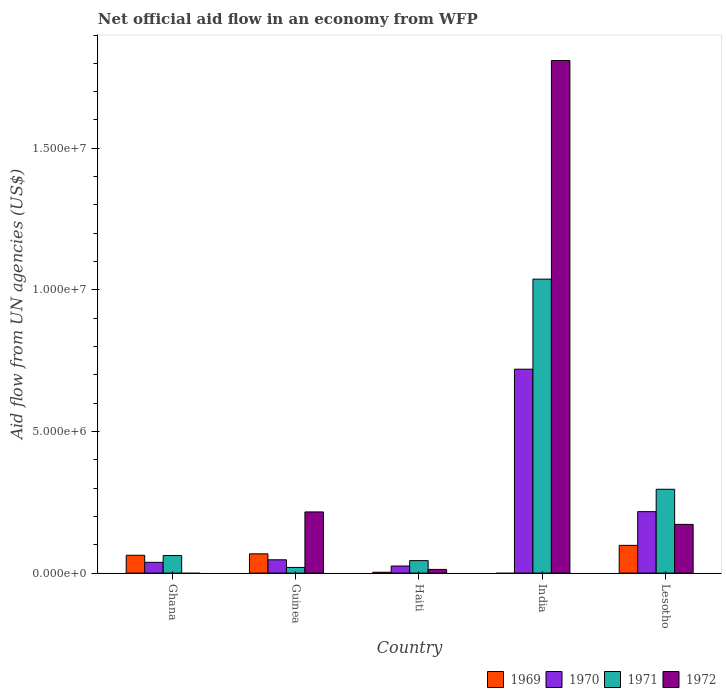How many different coloured bars are there?
Provide a succinct answer. 4. Are the number of bars on each tick of the X-axis equal?
Offer a terse response. No. How many bars are there on the 3rd tick from the left?
Ensure brevity in your answer.  4. How many bars are there on the 1st tick from the right?
Ensure brevity in your answer.  4. What is the label of the 3rd group of bars from the left?
Give a very brief answer. Haiti. In how many cases, is the number of bars for a given country not equal to the number of legend labels?
Offer a terse response. 2. Across all countries, what is the maximum net official aid flow in 1971?
Keep it short and to the point. 1.04e+07. In which country was the net official aid flow in 1972 maximum?
Provide a short and direct response. India. What is the total net official aid flow in 1970 in the graph?
Provide a succinct answer. 1.05e+07. What is the difference between the net official aid flow in 1970 in Ghana and that in India?
Keep it short and to the point. -6.82e+06. What is the average net official aid flow in 1971 per country?
Offer a terse response. 2.92e+06. What is the difference between the net official aid flow of/in 1971 and net official aid flow of/in 1969 in Guinea?
Keep it short and to the point. -4.80e+05. In how many countries, is the net official aid flow in 1969 greater than 12000000 US$?
Keep it short and to the point. 0. What is the ratio of the net official aid flow in 1971 in Haiti to that in Lesotho?
Your answer should be compact. 0.15. Is the net official aid flow in 1971 in Haiti less than that in India?
Give a very brief answer. Yes. What is the difference between the highest and the lowest net official aid flow in 1969?
Make the answer very short. 9.80e+05. In how many countries, is the net official aid flow in 1972 greater than the average net official aid flow in 1972 taken over all countries?
Offer a very short reply. 1. Is the sum of the net official aid flow in 1971 in Haiti and Lesotho greater than the maximum net official aid flow in 1972 across all countries?
Ensure brevity in your answer.  No. Is it the case that in every country, the sum of the net official aid flow in 1970 and net official aid flow in 1969 is greater than the sum of net official aid flow in 1971 and net official aid flow in 1972?
Provide a short and direct response. No. How many bars are there?
Offer a terse response. 18. Where does the legend appear in the graph?
Provide a succinct answer. Bottom right. How many legend labels are there?
Make the answer very short. 4. What is the title of the graph?
Ensure brevity in your answer.  Net official aid flow in an economy from WFP. Does "1973" appear as one of the legend labels in the graph?
Make the answer very short. No. What is the label or title of the X-axis?
Your answer should be compact. Country. What is the label or title of the Y-axis?
Provide a succinct answer. Aid flow from UN agencies (US$). What is the Aid flow from UN agencies (US$) in 1969 in Ghana?
Give a very brief answer. 6.30e+05. What is the Aid flow from UN agencies (US$) of 1970 in Ghana?
Keep it short and to the point. 3.80e+05. What is the Aid flow from UN agencies (US$) of 1971 in Ghana?
Keep it short and to the point. 6.20e+05. What is the Aid flow from UN agencies (US$) in 1972 in Ghana?
Offer a very short reply. 0. What is the Aid flow from UN agencies (US$) of 1969 in Guinea?
Offer a very short reply. 6.80e+05. What is the Aid flow from UN agencies (US$) in 1971 in Guinea?
Make the answer very short. 2.00e+05. What is the Aid flow from UN agencies (US$) in 1972 in Guinea?
Offer a very short reply. 2.16e+06. What is the Aid flow from UN agencies (US$) of 1969 in Haiti?
Your response must be concise. 3.00e+04. What is the Aid flow from UN agencies (US$) in 1971 in Haiti?
Your answer should be compact. 4.40e+05. What is the Aid flow from UN agencies (US$) in 1972 in Haiti?
Ensure brevity in your answer.  1.30e+05. What is the Aid flow from UN agencies (US$) of 1970 in India?
Ensure brevity in your answer.  7.20e+06. What is the Aid flow from UN agencies (US$) in 1971 in India?
Keep it short and to the point. 1.04e+07. What is the Aid flow from UN agencies (US$) in 1972 in India?
Keep it short and to the point. 1.81e+07. What is the Aid flow from UN agencies (US$) in 1969 in Lesotho?
Your response must be concise. 9.80e+05. What is the Aid flow from UN agencies (US$) of 1970 in Lesotho?
Provide a succinct answer. 2.17e+06. What is the Aid flow from UN agencies (US$) in 1971 in Lesotho?
Provide a short and direct response. 2.96e+06. What is the Aid flow from UN agencies (US$) of 1972 in Lesotho?
Your answer should be very brief. 1.72e+06. Across all countries, what is the maximum Aid flow from UN agencies (US$) in 1969?
Provide a short and direct response. 9.80e+05. Across all countries, what is the maximum Aid flow from UN agencies (US$) of 1970?
Your response must be concise. 7.20e+06. Across all countries, what is the maximum Aid flow from UN agencies (US$) of 1971?
Your answer should be compact. 1.04e+07. Across all countries, what is the maximum Aid flow from UN agencies (US$) of 1972?
Provide a short and direct response. 1.81e+07. Across all countries, what is the minimum Aid flow from UN agencies (US$) in 1969?
Your answer should be compact. 0. Across all countries, what is the minimum Aid flow from UN agencies (US$) in 1971?
Your response must be concise. 2.00e+05. Across all countries, what is the minimum Aid flow from UN agencies (US$) in 1972?
Keep it short and to the point. 0. What is the total Aid flow from UN agencies (US$) of 1969 in the graph?
Your answer should be compact. 2.32e+06. What is the total Aid flow from UN agencies (US$) of 1970 in the graph?
Your answer should be very brief. 1.05e+07. What is the total Aid flow from UN agencies (US$) in 1971 in the graph?
Give a very brief answer. 1.46e+07. What is the total Aid flow from UN agencies (US$) in 1972 in the graph?
Your response must be concise. 2.21e+07. What is the difference between the Aid flow from UN agencies (US$) of 1969 in Ghana and that in Guinea?
Keep it short and to the point. -5.00e+04. What is the difference between the Aid flow from UN agencies (US$) in 1970 in Ghana and that in Guinea?
Give a very brief answer. -9.00e+04. What is the difference between the Aid flow from UN agencies (US$) of 1971 in Ghana and that in Haiti?
Ensure brevity in your answer.  1.80e+05. What is the difference between the Aid flow from UN agencies (US$) in 1970 in Ghana and that in India?
Provide a short and direct response. -6.82e+06. What is the difference between the Aid flow from UN agencies (US$) of 1971 in Ghana and that in India?
Your answer should be compact. -9.76e+06. What is the difference between the Aid flow from UN agencies (US$) of 1969 in Ghana and that in Lesotho?
Offer a very short reply. -3.50e+05. What is the difference between the Aid flow from UN agencies (US$) in 1970 in Ghana and that in Lesotho?
Give a very brief answer. -1.79e+06. What is the difference between the Aid flow from UN agencies (US$) of 1971 in Ghana and that in Lesotho?
Keep it short and to the point. -2.34e+06. What is the difference between the Aid flow from UN agencies (US$) in 1969 in Guinea and that in Haiti?
Your response must be concise. 6.50e+05. What is the difference between the Aid flow from UN agencies (US$) of 1971 in Guinea and that in Haiti?
Your response must be concise. -2.40e+05. What is the difference between the Aid flow from UN agencies (US$) of 1972 in Guinea and that in Haiti?
Keep it short and to the point. 2.03e+06. What is the difference between the Aid flow from UN agencies (US$) in 1970 in Guinea and that in India?
Ensure brevity in your answer.  -6.73e+06. What is the difference between the Aid flow from UN agencies (US$) in 1971 in Guinea and that in India?
Offer a terse response. -1.02e+07. What is the difference between the Aid flow from UN agencies (US$) in 1972 in Guinea and that in India?
Keep it short and to the point. -1.59e+07. What is the difference between the Aid flow from UN agencies (US$) in 1969 in Guinea and that in Lesotho?
Your answer should be very brief. -3.00e+05. What is the difference between the Aid flow from UN agencies (US$) in 1970 in Guinea and that in Lesotho?
Make the answer very short. -1.70e+06. What is the difference between the Aid flow from UN agencies (US$) of 1971 in Guinea and that in Lesotho?
Keep it short and to the point. -2.76e+06. What is the difference between the Aid flow from UN agencies (US$) in 1972 in Guinea and that in Lesotho?
Your answer should be compact. 4.40e+05. What is the difference between the Aid flow from UN agencies (US$) in 1970 in Haiti and that in India?
Offer a terse response. -6.95e+06. What is the difference between the Aid flow from UN agencies (US$) in 1971 in Haiti and that in India?
Offer a very short reply. -9.94e+06. What is the difference between the Aid flow from UN agencies (US$) of 1972 in Haiti and that in India?
Give a very brief answer. -1.80e+07. What is the difference between the Aid flow from UN agencies (US$) in 1969 in Haiti and that in Lesotho?
Ensure brevity in your answer.  -9.50e+05. What is the difference between the Aid flow from UN agencies (US$) of 1970 in Haiti and that in Lesotho?
Give a very brief answer. -1.92e+06. What is the difference between the Aid flow from UN agencies (US$) of 1971 in Haiti and that in Lesotho?
Your response must be concise. -2.52e+06. What is the difference between the Aid flow from UN agencies (US$) of 1972 in Haiti and that in Lesotho?
Your response must be concise. -1.59e+06. What is the difference between the Aid flow from UN agencies (US$) in 1970 in India and that in Lesotho?
Give a very brief answer. 5.03e+06. What is the difference between the Aid flow from UN agencies (US$) in 1971 in India and that in Lesotho?
Keep it short and to the point. 7.42e+06. What is the difference between the Aid flow from UN agencies (US$) of 1972 in India and that in Lesotho?
Offer a very short reply. 1.64e+07. What is the difference between the Aid flow from UN agencies (US$) in 1969 in Ghana and the Aid flow from UN agencies (US$) in 1970 in Guinea?
Make the answer very short. 1.60e+05. What is the difference between the Aid flow from UN agencies (US$) of 1969 in Ghana and the Aid flow from UN agencies (US$) of 1971 in Guinea?
Offer a very short reply. 4.30e+05. What is the difference between the Aid flow from UN agencies (US$) in 1969 in Ghana and the Aid flow from UN agencies (US$) in 1972 in Guinea?
Make the answer very short. -1.53e+06. What is the difference between the Aid flow from UN agencies (US$) in 1970 in Ghana and the Aid flow from UN agencies (US$) in 1971 in Guinea?
Your answer should be compact. 1.80e+05. What is the difference between the Aid flow from UN agencies (US$) in 1970 in Ghana and the Aid flow from UN agencies (US$) in 1972 in Guinea?
Ensure brevity in your answer.  -1.78e+06. What is the difference between the Aid flow from UN agencies (US$) of 1971 in Ghana and the Aid flow from UN agencies (US$) of 1972 in Guinea?
Provide a short and direct response. -1.54e+06. What is the difference between the Aid flow from UN agencies (US$) of 1969 in Ghana and the Aid flow from UN agencies (US$) of 1970 in Haiti?
Make the answer very short. 3.80e+05. What is the difference between the Aid flow from UN agencies (US$) in 1970 in Ghana and the Aid flow from UN agencies (US$) in 1971 in Haiti?
Make the answer very short. -6.00e+04. What is the difference between the Aid flow from UN agencies (US$) of 1970 in Ghana and the Aid flow from UN agencies (US$) of 1972 in Haiti?
Make the answer very short. 2.50e+05. What is the difference between the Aid flow from UN agencies (US$) in 1971 in Ghana and the Aid flow from UN agencies (US$) in 1972 in Haiti?
Give a very brief answer. 4.90e+05. What is the difference between the Aid flow from UN agencies (US$) of 1969 in Ghana and the Aid flow from UN agencies (US$) of 1970 in India?
Provide a succinct answer. -6.57e+06. What is the difference between the Aid flow from UN agencies (US$) of 1969 in Ghana and the Aid flow from UN agencies (US$) of 1971 in India?
Your response must be concise. -9.75e+06. What is the difference between the Aid flow from UN agencies (US$) in 1969 in Ghana and the Aid flow from UN agencies (US$) in 1972 in India?
Your response must be concise. -1.75e+07. What is the difference between the Aid flow from UN agencies (US$) of 1970 in Ghana and the Aid flow from UN agencies (US$) of 1971 in India?
Your answer should be compact. -1.00e+07. What is the difference between the Aid flow from UN agencies (US$) of 1970 in Ghana and the Aid flow from UN agencies (US$) of 1972 in India?
Offer a terse response. -1.77e+07. What is the difference between the Aid flow from UN agencies (US$) in 1971 in Ghana and the Aid flow from UN agencies (US$) in 1972 in India?
Your response must be concise. -1.75e+07. What is the difference between the Aid flow from UN agencies (US$) of 1969 in Ghana and the Aid flow from UN agencies (US$) of 1970 in Lesotho?
Keep it short and to the point. -1.54e+06. What is the difference between the Aid flow from UN agencies (US$) of 1969 in Ghana and the Aid flow from UN agencies (US$) of 1971 in Lesotho?
Your response must be concise. -2.33e+06. What is the difference between the Aid flow from UN agencies (US$) in 1969 in Ghana and the Aid flow from UN agencies (US$) in 1972 in Lesotho?
Your response must be concise. -1.09e+06. What is the difference between the Aid flow from UN agencies (US$) of 1970 in Ghana and the Aid flow from UN agencies (US$) of 1971 in Lesotho?
Your answer should be compact. -2.58e+06. What is the difference between the Aid flow from UN agencies (US$) in 1970 in Ghana and the Aid flow from UN agencies (US$) in 1972 in Lesotho?
Offer a very short reply. -1.34e+06. What is the difference between the Aid flow from UN agencies (US$) of 1971 in Ghana and the Aid flow from UN agencies (US$) of 1972 in Lesotho?
Offer a very short reply. -1.10e+06. What is the difference between the Aid flow from UN agencies (US$) of 1970 in Guinea and the Aid flow from UN agencies (US$) of 1971 in Haiti?
Your answer should be compact. 3.00e+04. What is the difference between the Aid flow from UN agencies (US$) in 1970 in Guinea and the Aid flow from UN agencies (US$) in 1972 in Haiti?
Your response must be concise. 3.40e+05. What is the difference between the Aid flow from UN agencies (US$) in 1969 in Guinea and the Aid flow from UN agencies (US$) in 1970 in India?
Your answer should be very brief. -6.52e+06. What is the difference between the Aid flow from UN agencies (US$) in 1969 in Guinea and the Aid flow from UN agencies (US$) in 1971 in India?
Ensure brevity in your answer.  -9.70e+06. What is the difference between the Aid flow from UN agencies (US$) in 1969 in Guinea and the Aid flow from UN agencies (US$) in 1972 in India?
Your answer should be compact. -1.74e+07. What is the difference between the Aid flow from UN agencies (US$) of 1970 in Guinea and the Aid flow from UN agencies (US$) of 1971 in India?
Your answer should be very brief. -9.91e+06. What is the difference between the Aid flow from UN agencies (US$) of 1970 in Guinea and the Aid flow from UN agencies (US$) of 1972 in India?
Offer a very short reply. -1.76e+07. What is the difference between the Aid flow from UN agencies (US$) of 1971 in Guinea and the Aid flow from UN agencies (US$) of 1972 in India?
Offer a very short reply. -1.79e+07. What is the difference between the Aid flow from UN agencies (US$) in 1969 in Guinea and the Aid flow from UN agencies (US$) in 1970 in Lesotho?
Offer a terse response. -1.49e+06. What is the difference between the Aid flow from UN agencies (US$) of 1969 in Guinea and the Aid flow from UN agencies (US$) of 1971 in Lesotho?
Provide a short and direct response. -2.28e+06. What is the difference between the Aid flow from UN agencies (US$) of 1969 in Guinea and the Aid flow from UN agencies (US$) of 1972 in Lesotho?
Your answer should be very brief. -1.04e+06. What is the difference between the Aid flow from UN agencies (US$) of 1970 in Guinea and the Aid flow from UN agencies (US$) of 1971 in Lesotho?
Offer a very short reply. -2.49e+06. What is the difference between the Aid flow from UN agencies (US$) in 1970 in Guinea and the Aid flow from UN agencies (US$) in 1972 in Lesotho?
Make the answer very short. -1.25e+06. What is the difference between the Aid flow from UN agencies (US$) in 1971 in Guinea and the Aid flow from UN agencies (US$) in 1972 in Lesotho?
Offer a very short reply. -1.52e+06. What is the difference between the Aid flow from UN agencies (US$) of 1969 in Haiti and the Aid flow from UN agencies (US$) of 1970 in India?
Ensure brevity in your answer.  -7.17e+06. What is the difference between the Aid flow from UN agencies (US$) of 1969 in Haiti and the Aid flow from UN agencies (US$) of 1971 in India?
Provide a short and direct response. -1.04e+07. What is the difference between the Aid flow from UN agencies (US$) in 1969 in Haiti and the Aid flow from UN agencies (US$) in 1972 in India?
Your answer should be compact. -1.81e+07. What is the difference between the Aid flow from UN agencies (US$) of 1970 in Haiti and the Aid flow from UN agencies (US$) of 1971 in India?
Your answer should be very brief. -1.01e+07. What is the difference between the Aid flow from UN agencies (US$) of 1970 in Haiti and the Aid flow from UN agencies (US$) of 1972 in India?
Ensure brevity in your answer.  -1.78e+07. What is the difference between the Aid flow from UN agencies (US$) in 1971 in Haiti and the Aid flow from UN agencies (US$) in 1972 in India?
Ensure brevity in your answer.  -1.77e+07. What is the difference between the Aid flow from UN agencies (US$) in 1969 in Haiti and the Aid flow from UN agencies (US$) in 1970 in Lesotho?
Make the answer very short. -2.14e+06. What is the difference between the Aid flow from UN agencies (US$) of 1969 in Haiti and the Aid flow from UN agencies (US$) of 1971 in Lesotho?
Ensure brevity in your answer.  -2.93e+06. What is the difference between the Aid flow from UN agencies (US$) in 1969 in Haiti and the Aid flow from UN agencies (US$) in 1972 in Lesotho?
Keep it short and to the point. -1.69e+06. What is the difference between the Aid flow from UN agencies (US$) in 1970 in Haiti and the Aid flow from UN agencies (US$) in 1971 in Lesotho?
Your answer should be very brief. -2.71e+06. What is the difference between the Aid flow from UN agencies (US$) in 1970 in Haiti and the Aid flow from UN agencies (US$) in 1972 in Lesotho?
Your response must be concise. -1.47e+06. What is the difference between the Aid flow from UN agencies (US$) of 1971 in Haiti and the Aid flow from UN agencies (US$) of 1972 in Lesotho?
Your response must be concise. -1.28e+06. What is the difference between the Aid flow from UN agencies (US$) of 1970 in India and the Aid flow from UN agencies (US$) of 1971 in Lesotho?
Provide a short and direct response. 4.24e+06. What is the difference between the Aid flow from UN agencies (US$) of 1970 in India and the Aid flow from UN agencies (US$) of 1972 in Lesotho?
Offer a very short reply. 5.48e+06. What is the difference between the Aid flow from UN agencies (US$) in 1971 in India and the Aid flow from UN agencies (US$) in 1972 in Lesotho?
Provide a short and direct response. 8.66e+06. What is the average Aid flow from UN agencies (US$) in 1969 per country?
Make the answer very short. 4.64e+05. What is the average Aid flow from UN agencies (US$) of 1970 per country?
Ensure brevity in your answer.  2.09e+06. What is the average Aid flow from UN agencies (US$) in 1971 per country?
Ensure brevity in your answer.  2.92e+06. What is the average Aid flow from UN agencies (US$) in 1972 per country?
Offer a very short reply. 4.42e+06. What is the difference between the Aid flow from UN agencies (US$) of 1969 and Aid flow from UN agencies (US$) of 1970 in Ghana?
Provide a short and direct response. 2.50e+05. What is the difference between the Aid flow from UN agencies (US$) of 1969 and Aid flow from UN agencies (US$) of 1971 in Guinea?
Offer a very short reply. 4.80e+05. What is the difference between the Aid flow from UN agencies (US$) of 1969 and Aid flow from UN agencies (US$) of 1972 in Guinea?
Your response must be concise. -1.48e+06. What is the difference between the Aid flow from UN agencies (US$) of 1970 and Aid flow from UN agencies (US$) of 1971 in Guinea?
Ensure brevity in your answer.  2.70e+05. What is the difference between the Aid flow from UN agencies (US$) in 1970 and Aid flow from UN agencies (US$) in 1972 in Guinea?
Offer a very short reply. -1.69e+06. What is the difference between the Aid flow from UN agencies (US$) in 1971 and Aid flow from UN agencies (US$) in 1972 in Guinea?
Your answer should be very brief. -1.96e+06. What is the difference between the Aid flow from UN agencies (US$) of 1969 and Aid flow from UN agencies (US$) of 1971 in Haiti?
Provide a succinct answer. -4.10e+05. What is the difference between the Aid flow from UN agencies (US$) in 1969 and Aid flow from UN agencies (US$) in 1972 in Haiti?
Your response must be concise. -1.00e+05. What is the difference between the Aid flow from UN agencies (US$) in 1970 and Aid flow from UN agencies (US$) in 1971 in Haiti?
Make the answer very short. -1.90e+05. What is the difference between the Aid flow from UN agencies (US$) in 1970 and Aid flow from UN agencies (US$) in 1971 in India?
Provide a short and direct response. -3.18e+06. What is the difference between the Aid flow from UN agencies (US$) of 1970 and Aid flow from UN agencies (US$) of 1972 in India?
Provide a succinct answer. -1.09e+07. What is the difference between the Aid flow from UN agencies (US$) of 1971 and Aid flow from UN agencies (US$) of 1972 in India?
Your answer should be very brief. -7.72e+06. What is the difference between the Aid flow from UN agencies (US$) in 1969 and Aid flow from UN agencies (US$) in 1970 in Lesotho?
Offer a very short reply. -1.19e+06. What is the difference between the Aid flow from UN agencies (US$) of 1969 and Aid flow from UN agencies (US$) of 1971 in Lesotho?
Keep it short and to the point. -1.98e+06. What is the difference between the Aid flow from UN agencies (US$) in 1969 and Aid flow from UN agencies (US$) in 1972 in Lesotho?
Keep it short and to the point. -7.40e+05. What is the difference between the Aid flow from UN agencies (US$) of 1970 and Aid flow from UN agencies (US$) of 1971 in Lesotho?
Your answer should be very brief. -7.90e+05. What is the difference between the Aid flow from UN agencies (US$) of 1971 and Aid flow from UN agencies (US$) of 1972 in Lesotho?
Your response must be concise. 1.24e+06. What is the ratio of the Aid flow from UN agencies (US$) of 1969 in Ghana to that in Guinea?
Your answer should be very brief. 0.93. What is the ratio of the Aid flow from UN agencies (US$) of 1970 in Ghana to that in Guinea?
Give a very brief answer. 0.81. What is the ratio of the Aid flow from UN agencies (US$) in 1970 in Ghana to that in Haiti?
Your answer should be very brief. 1.52. What is the ratio of the Aid flow from UN agencies (US$) in 1971 in Ghana to that in Haiti?
Your answer should be compact. 1.41. What is the ratio of the Aid flow from UN agencies (US$) in 1970 in Ghana to that in India?
Make the answer very short. 0.05. What is the ratio of the Aid flow from UN agencies (US$) in 1971 in Ghana to that in India?
Offer a terse response. 0.06. What is the ratio of the Aid flow from UN agencies (US$) of 1969 in Ghana to that in Lesotho?
Your answer should be very brief. 0.64. What is the ratio of the Aid flow from UN agencies (US$) of 1970 in Ghana to that in Lesotho?
Provide a succinct answer. 0.18. What is the ratio of the Aid flow from UN agencies (US$) in 1971 in Ghana to that in Lesotho?
Offer a terse response. 0.21. What is the ratio of the Aid flow from UN agencies (US$) of 1969 in Guinea to that in Haiti?
Your answer should be very brief. 22.67. What is the ratio of the Aid flow from UN agencies (US$) in 1970 in Guinea to that in Haiti?
Ensure brevity in your answer.  1.88. What is the ratio of the Aid flow from UN agencies (US$) of 1971 in Guinea to that in Haiti?
Offer a very short reply. 0.45. What is the ratio of the Aid flow from UN agencies (US$) of 1972 in Guinea to that in Haiti?
Your answer should be compact. 16.62. What is the ratio of the Aid flow from UN agencies (US$) in 1970 in Guinea to that in India?
Offer a very short reply. 0.07. What is the ratio of the Aid flow from UN agencies (US$) in 1971 in Guinea to that in India?
Ensure brevity in your answer.  0.02. What is the ratio of the Aid flow from UN agencies (US$) of 1972 in Guinea to that in India?
Make the answer very short. 0.12. What is the ratio of the Aid flow from UN agencies (US$) in 1969 in Guinea to that in Lesotho?
Make the answer very short. 0.69. What is the ratio of the Aid flow from UN agencies (US$) of 1970 in Guinea to that in Lesotho?
Make the answer very short. 0.22. What is the ratio of the Aid flow from UN agencies (US$) in 1971 in Guinea to that in Lesotho?
Offer a terse response. 0.07. What is the ratio of the Aid flow from UN agencies (US$) of 1972 in Guinea to that in Lesotho?
Keep it short and to the point. 1.26. What is the ratio of the Aid flow from UN agencies (US$) of 1970 in Haiti to that in India?
Provide a short and direct response. 0.03. What is the ratio of the Aid flow from UN agencies (US$) in 1971 in Haiti to that in India?
Your answer should be very brief. 0.04. What is the ratio of the Aid flow from UN agencies (US$) in 1972 in Haiti to that in India?
Keep it short and to the point. 0.01. What is the ratio of the Aid flow from UN agencies (US$) of 1969 in Haiti to that in Lesotho?
Ensure brevity in your answer.  0.03. What is the ratio of the Aid flow from UN agencies (US$) of 1970 in Haiti to that in Lesotho?
Your answer should be compact. 0.12. What is the ratio of the Aid flow from UN agencies (US$) of 1971 in Haiti to that in Lesotho?
Ensure brevity in your answer.  0.15. What is the ratio of the Aid flow from UN agencies (US$) in 1972 in Haiti to that in Lesotho?
Make the answer very short. 0.08. What is the ratio of the Aid flow from UN agencies (US$) in 1970 in India to that in Lesotho?
Your response must be concise. 3.32. What is the ratio of the Aid flow from UN agencies (US$) in 1971 in India to that in Lesotho?
Give a very brief answer. 3.51. What is the ratio of the Aid flow from UN agencies (US$) in 1972 in India to that in Lesotho?
Your answer should be compact. 10.52. What is the difference between the highest and the second highest Aid flow from UN agencies (US$) in 1970?
Provide a succinct answer. 5.03e+06. What is the difference between the highest and the second highest Aid flow from UN agencies (US$) of 1971?
Your answer should be very brief. 7.42e+06. What is the difference between the highest and the second highest Aid flow from UN agencies (US$) of 1972?
Your response must be concise. 1.59e+07. What is the difference between the highest and the lowest Aid flow from UN agencies (US$) of 1969?
Offer a terse response. 9.80e+05. What is the difference between the highest and the lowest Aid flow from UN agencies (US$) of 1970?
Give a very brief answer. 6.95e+06. What is the difference between the highest and the lowest Aid flow from UN agencies (US$) of 1971?
Your response must be concise. 1.02e+07. What is the difference between the highest and the lowest Aid flow from UN agencies (US$) in 1972?
Offer a very short reply. 1.81e+07. 